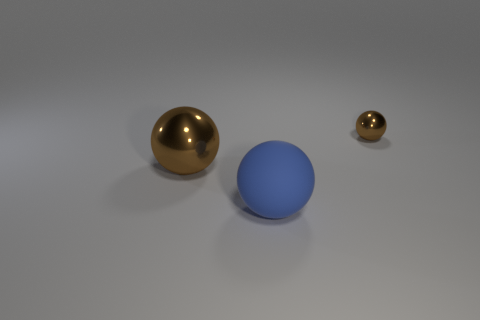There is a thing that is the same color as the big metal sphere; what is its shape? The object that shares the same color as the large golden sphere appears to be another sphere, indicating there are two spherical objects in the image with a reflective gold hue. 